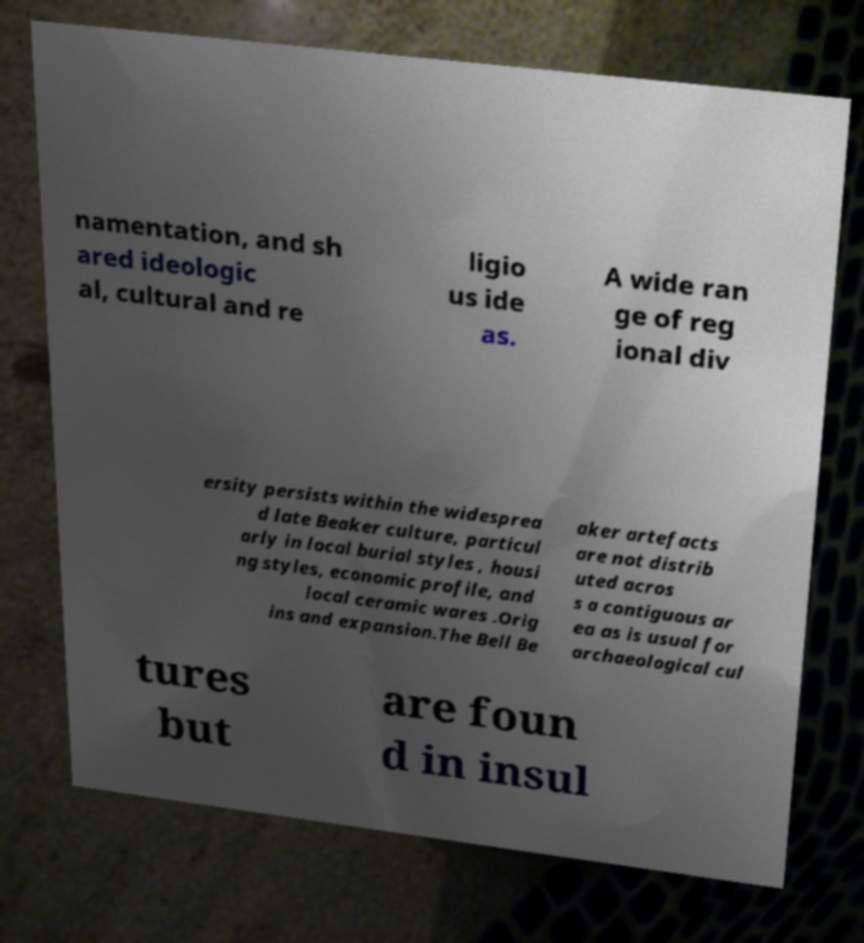Could you assist in decoding the text presented in this image and type it out clearly? namentation, and sh ared ideologic al, cultural and re ligio us ide as. A wide ran ge of reg ional div ersity persists within the widesprea d late Beaker culture, particul arly in local burial styles , housi ng styles, economic profile, and local ceramic wares .Orig ins and expansion.The Bell Be aker artefacts are not distrib uted acros s a contiguous ar ea as is usual for archaeological cul tures but are foun d in insul 